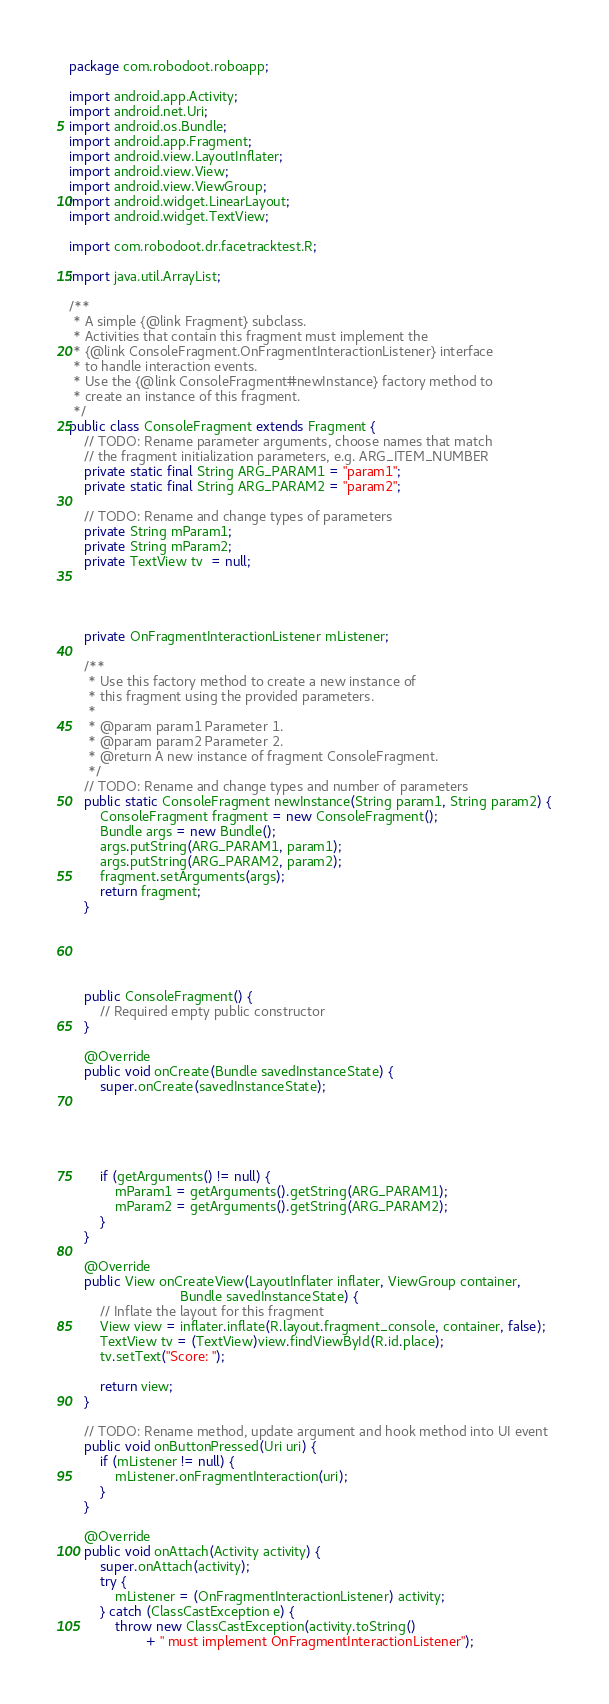Convert code to text. <code><loc_0><loc_0><loc_500><loc_500><_Java_>package com.robodoot.roboapp;

import android.app.Activity;
import android.net.Uri;
import android.os.Bundle;
import android.app.Fragment;
import android.view.LayoutInflater;
import android.view.View;
import android.view.ViewGroup;
import android.widget.LinearLayout;
import android.widget.TextView;

import com.robodoot.dr.facetracktest.R;

import java.util.ArrayList;

/**
 * A simple {@link Fragment} subclass.
 * Activities that contain this fragment must implement the
 * {@link ConsoleFragment.OnFragmentInteractionListener} interface
 * to handle interaction events.
 * Use the {@link ConsoleFragment#newInstance} factory method to
 * create an instance of this fragment.
 */
public class ConsoleFragment extends Fragment {
    // TODO: Rename parameter arguments, choose names that match
    // the fragment initialization parameters, e.g. ARG_ITEM_NUMBER
    private static final String ARG_PARAM1 = "param1";
    private static final String ARG_PARAM2 = "param2";

    // TODO: Rename and change types of parameters
    private String mParam1;
    private String mParam2;
    private TextView tv  = null;




    private OnFragmentInteractionListener mListener;

    /**
     * Use this factory method to create a new instance of
     * this fragment using the provided parameters.
     *
     * @param param1 Parameter 1.
     * @param param2 Parameter 2.
     * @return A new instance of fragment ConsoleFragment.
     */
    // TODO: Rename and change types and number of parameters
    public static ConsoleFragment newInstance(String param1, String param2) {
        ConsoleFragment fragment = new ConsoleFragment();
        Bundle args = new Bundle();
        args.putString(ARG_PARAM1, param1);
        args.putString(ARG_PARAM2, param2);
        fragment.setArguments(args);
        return fragment;
    }





    public ConsoleFragment() {
        // Required empty public constructor
    }

    @Override
    public void onCreate(Bundle savedInstanceState) {
        super.onCreate(savedInstanceState);





        if (getArguments() != null) {
            mParam1 = getArguments().getString(ARG_PARAM1);
            mParam2 = getArguments().getString(ARG_PARAM2);
        }
    }

    @Override
    public View onCreateView(LayoutInflater inflater, ViewGroup container,
                             Bundle savedInstanceState) {
        // Inflate the layout for this fragment
        View view = inflater.inflate(R.layout.fragment_console, container, false);
        TextView tv = (TextView)view.findViewById(R.id.place);
        tv.setText("Score: ");

        return view;
    }

    // TODO: Rename method, update argument and hook method into UI event
    public void onButtonPressed(Uri uri) {
        if (mListener != null) {
            mListener.onFragmentInteraction(uri);
        }
    }

    @Override
    public void onAttach(Activity activity) {
        super.onAttach(activity);
        try {
            mListener = (OnFragmentInteractionListener) activity;
        } catch (ClassCastException e) {
            throw new ClassCastException(activity.toString()
                    + " must implement OnFragmentInteractionListener");</code> 